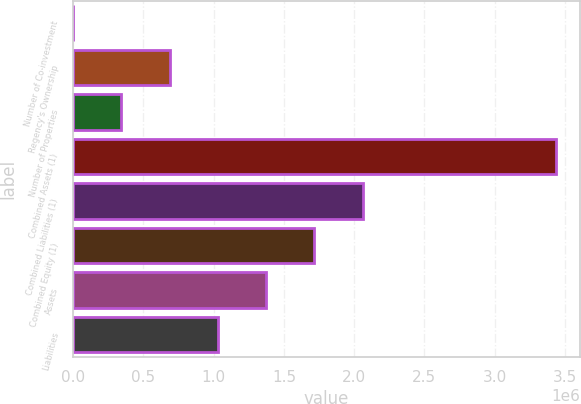Convert chart. <chart><loc_0><loc_0><loc_500><loc_500><bar_chart><fcel>Number of Co-investment<fcel>Regency's Ownership<fcel>Number of Properties<fcel>Combined Assets (1)<fcel>Combined Liabilities (1)<fcel>Combined Equity (1)<fcel>Assets<fcel>Liabilities<nl><fcel>19<fcel>687006<fcel>343512<fcel>3.43495e+06<fcel>2.06098e+06<fcel>1.71749e+06<fcel>1.37399e+06<fcel>1.0305e+06<nl></chart> 